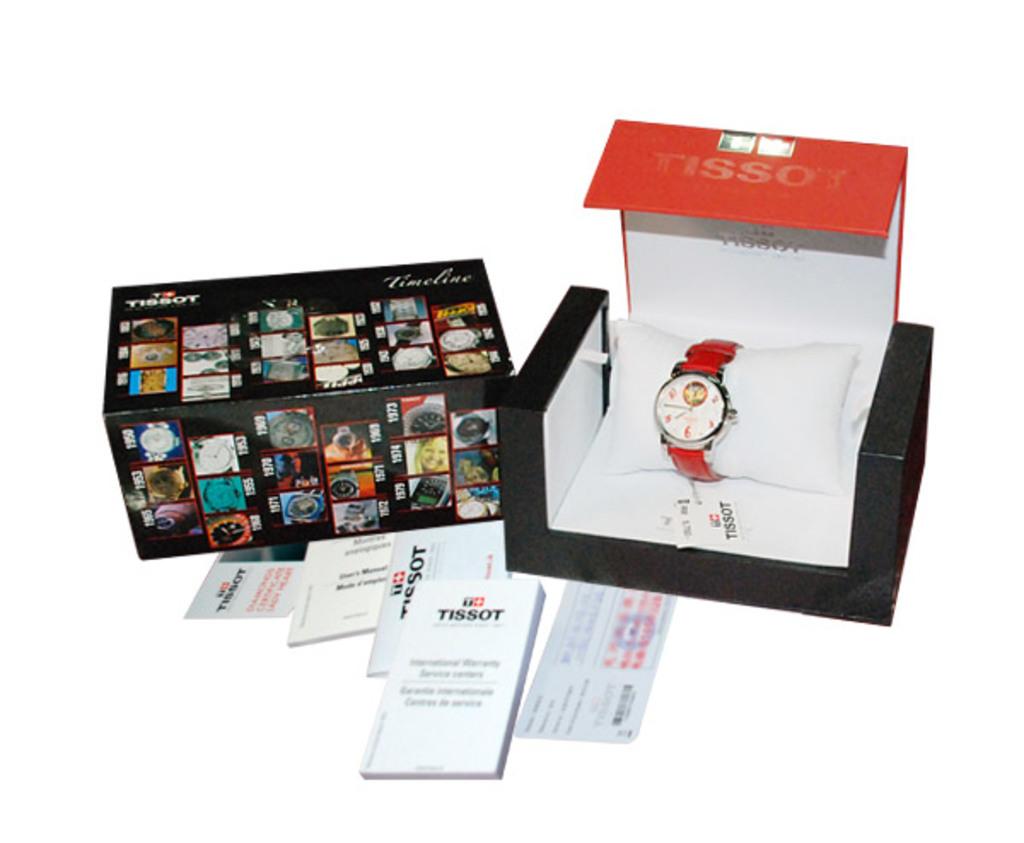What's the name on the red box lid?
Provide a short and direct response. Tissot. 